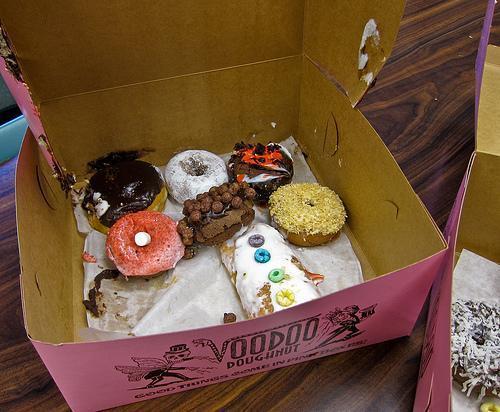How many doughnuts are in the box?
Give a very brief answer. 7. How many Fruit Loops are on the doughnut?
Give a very brief answer. 4. 